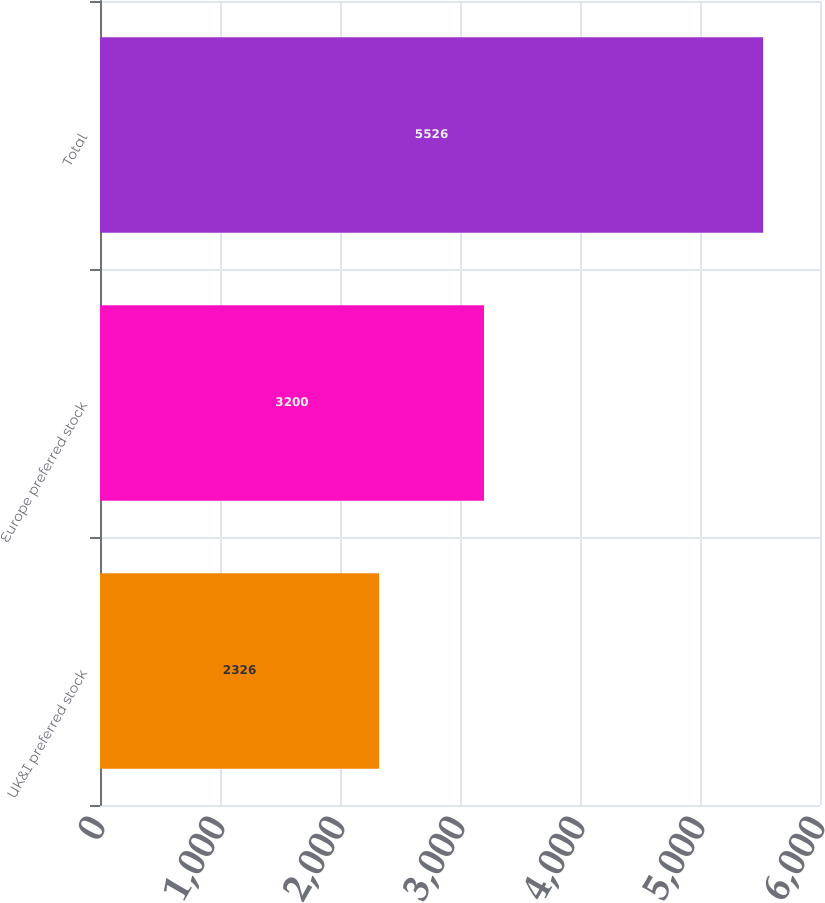<chart> <loc_0><loc_0><loc_500><loc_500><bar_chart><fcel>UK&I preferred stock<fcel>Europe preferred stock<fcel>Total<nl><fcel>2326<fcel>3200<fcel>5526<nl></chart> 